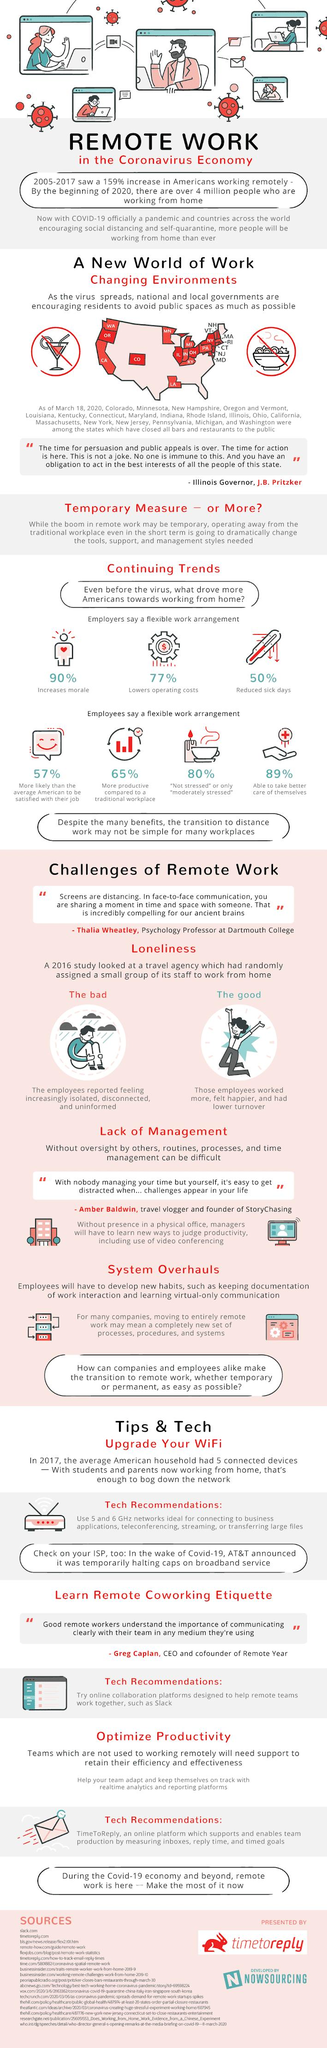Point out several critical features in this image. Flexible work arrangements have been shown to benefit employers by increasing morale, lowering operating costs, and reducing sick days. To ensure a successful remote working experience, it is crucial to upgrade your WiFi, learn remote coworking etiquette, and optimize productivity by prioritizing time management and communication, leveraging technology, and maintaining a healthy work-life balance. The trend of reduced sick days is continuing, according to the thermometer. The benefits of working from home can be negatively impacted when employees experience feelings of isolation, disconnection, and lack of information, leading to a decrease in overall job satisfaction and productivity. Flexible work arrangements provide 80% of employees with the ability to not feel stressed or only moderately stressed, reducing their overall level of stress and promoting a healthy work-life balance. 